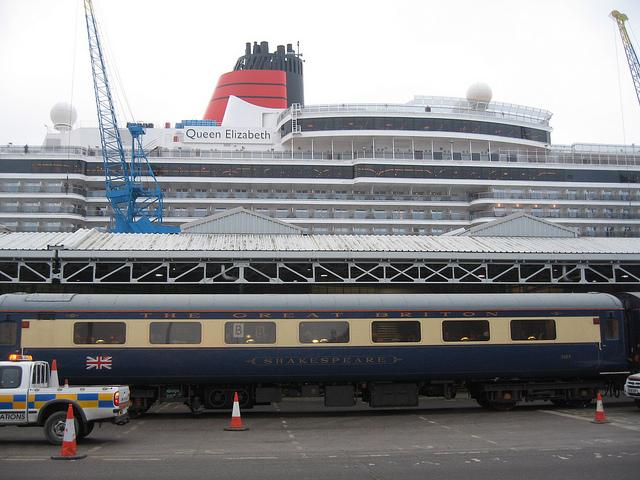How many trucks are there?
Answer briefly. 1. Where are the cones?
Keep it brief. Parking lot. How many levels does this ship have?
Be succinct. 6. 